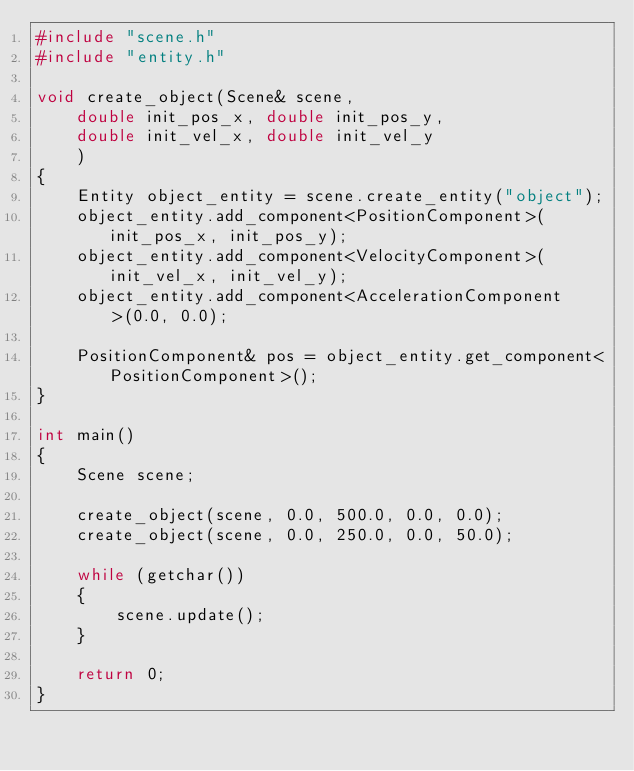Convert code to text. <code><loc_0><loc_0><loc_500><loc_500><_C++_>#include "scene.h"
#include "entity.h"

void create_object(Scene& scene,
    double init_pos_x, double init_pos_y,
    double init_vel_x, double init_vel_y
    )
{
    Entity object_entity = scene.create_entity("object");
    object_entity.add_component<PositionComponent>(init_pos_x, init_pos_y);
    object_entity.add_component<VelocityComponent>(init_vel_x, init_vel_y);
    object_entity.add_component<AccelerationComponent>(0.0, 0.0);

    PositionComponent& pos = object_entity.get_component<PositionComponent>();
}

int main()
{
    Scene scene;
    
    create_object(scene, 0.0, 500.0, 0.0, 0.0);
    create_object(scene, 0.0, 250.0, 0.0, 50.0);

    while (getchar())
    {
        scene.update();
    }
    
    return 0;
}</code> 